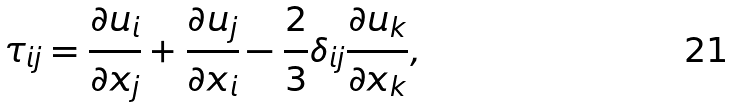Convert formula to latex. <formula><loc_0><loc_0><loc_500><loc_500>\tau _ { i j } = \frac { \partial { u _ { i } } } { \partial { x _ { j } } } + \frac { \partial { u _ { j } } } { \partial { x _ { i } } } - \frac { 2 } { 3 } \delta _ { i j } \frac { \partial { u _ { k } } } { \partial { x _ { k } } } ,</formula> 